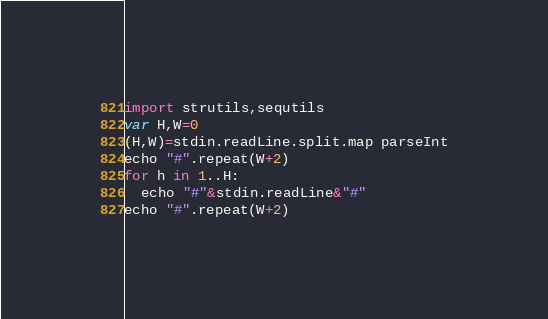Convert code to text. <code><loc_0><loc_0><loc_500><loc_500><_Nim_>import strutils,sequtils
var H,W=0
(H,W)=stdin.readLine.split.map parseInt
echo "#".repeat(W+2)
for h in 1..H:
  echo "#"&stdin.readLine&"#"
echo "#".repeat(W+2)</code> 